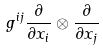Convert formula to latex. <formula><loc_0><loc_0><loc_500><loc_500>g ^ { i j } \frac { \partial } { \partial x _ { i } } \otimes \frac { \partial } { \partial x _ { j } }</formula> 